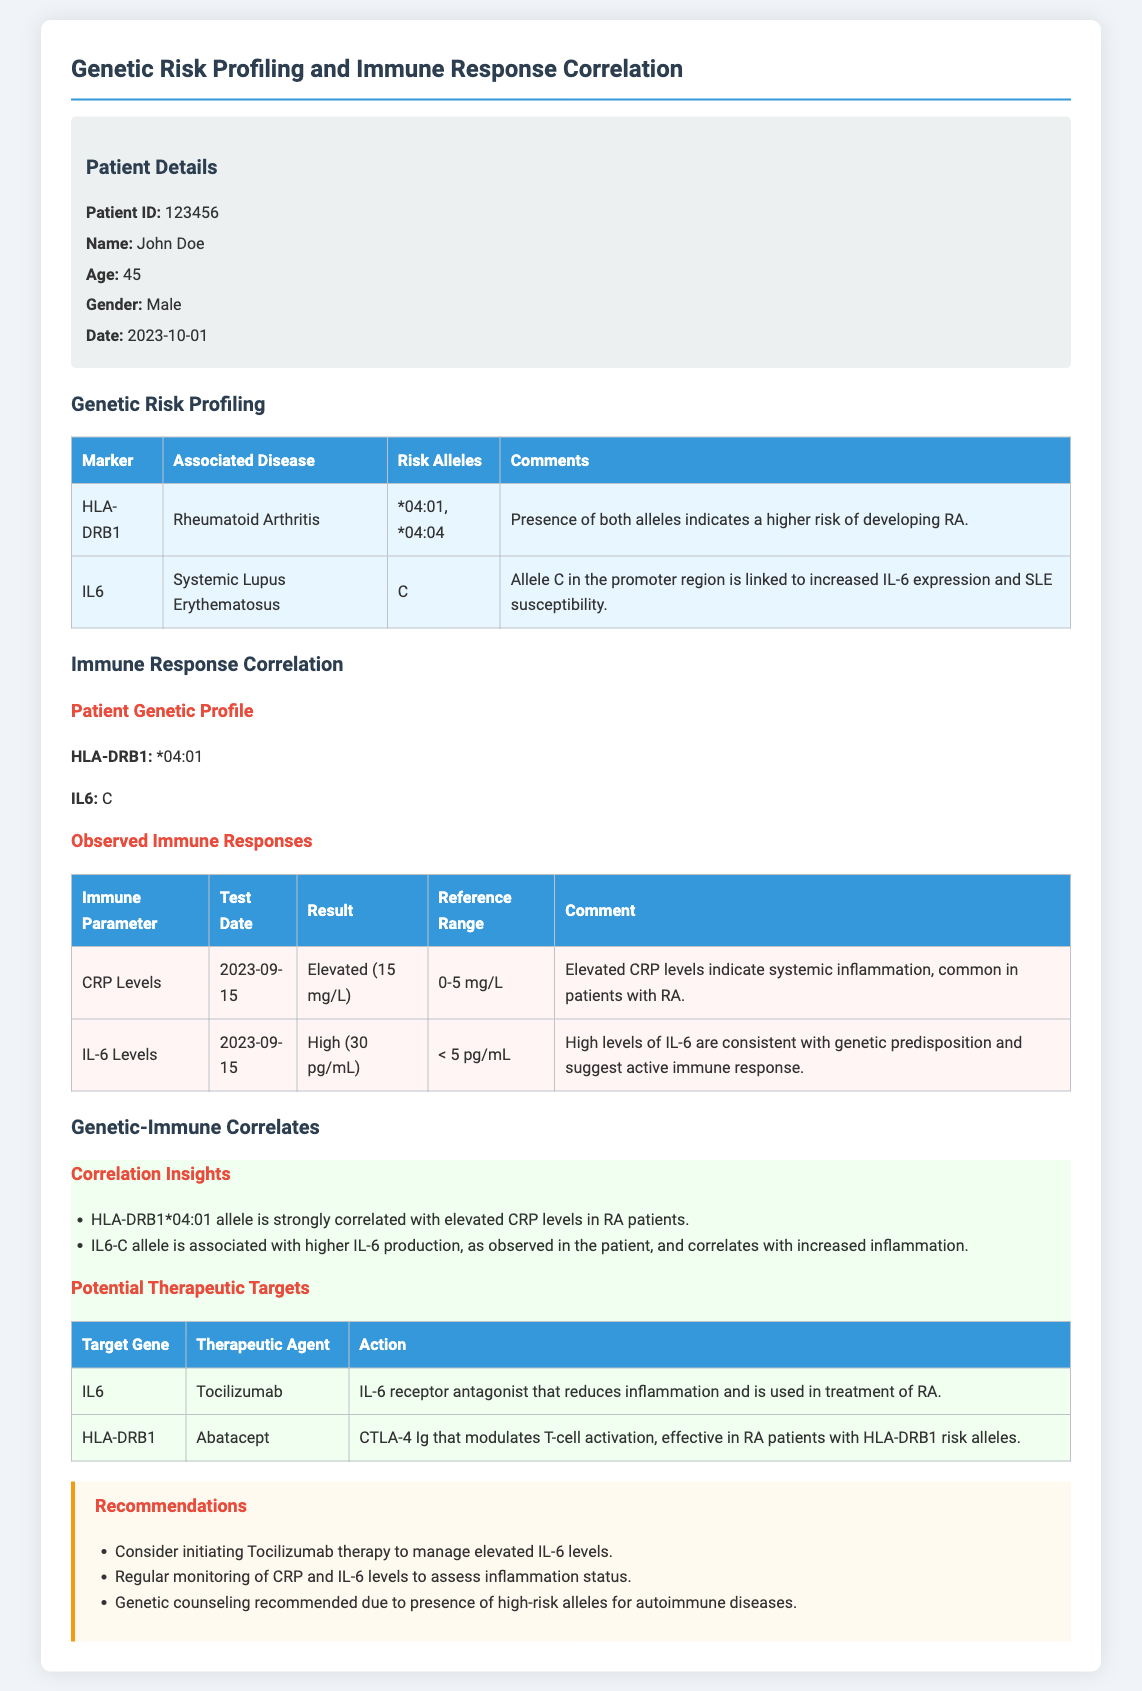What is the patient's name? The patient's name is listed in the patient details section of the document.
Answer: John Doe What is the patient's age? The patient's age is mentioned directly in the patient details.
Answer: 45 Which genetic marker is associated with Rheumatoid Arthritis? The table under Genetic Risk Profiling lists the markers and their associated diseases.
Answer: HLA-DRB1 What is the result for IL-6 Levels? The observed immune response for IL-6 Levels includes the results presented in the table.
Answer: High (30 pg/mL) What allele is linked to increased IL-6 expression? The comments section of the genetic profiling mentions this information.
Answer: C Which therapeutic agent is used for targeting IL-6? The table under Potential Therapeutic Targets indicates specific therapeutic agents for certain genes.
Answer: Tocilizumab What recommendations are made concerning IL-6 levels? The recommendations section outlines specific actions for managing elevated IL-6 levels.
Answer: Consider initiating Tocilizumab therapy How is HLA-DRB1*04:01 allele correlated with CRP levels? The Correlation Insights section details the relationship between this allele and CRP levels.
Answer: Strongly correlated with elevated CRP levels What is the date of the patient's test for CRP Levels? The date is listed in the Observed Immune Responses table for CRP levels.
Answer: 2023-09-15 